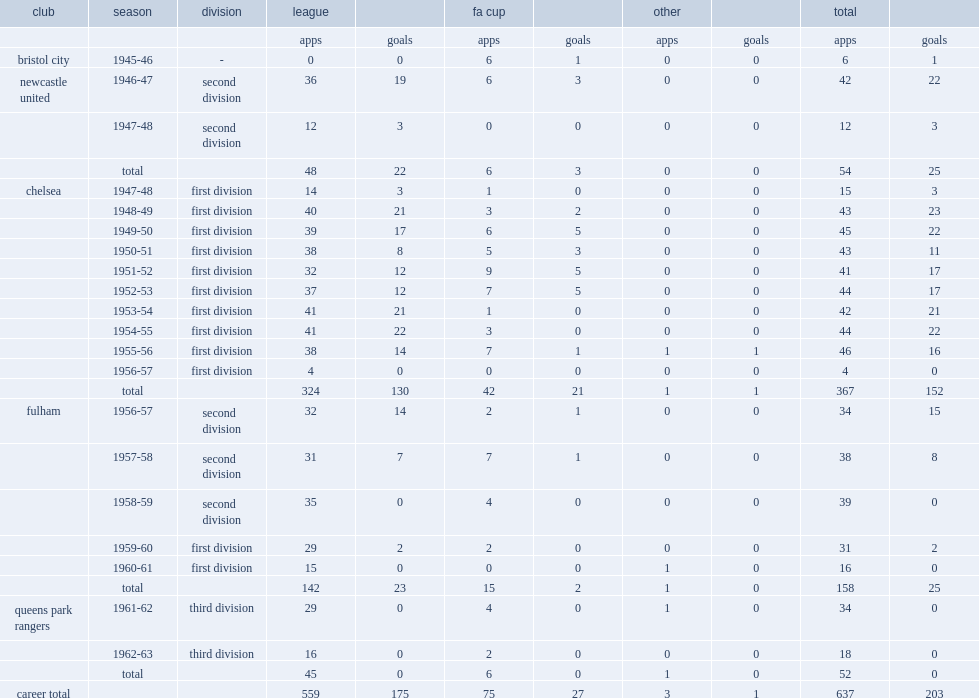How many games did bentley play for the chelsea club in the 1954-55 season? 367.0. 